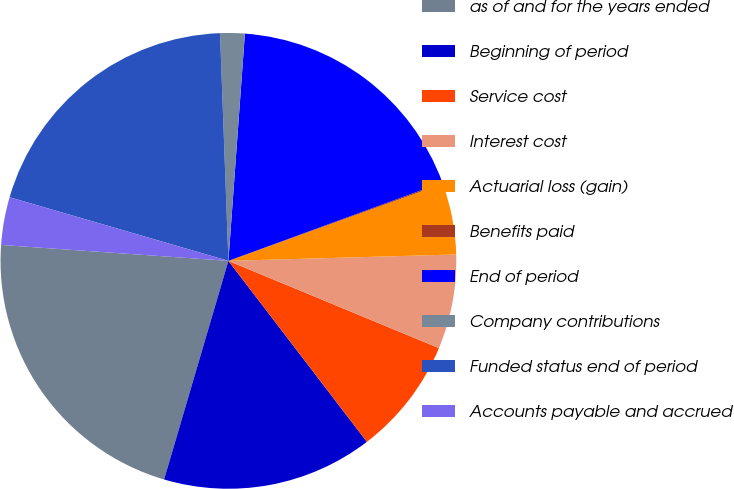Convert chart to OTSL. <chart><loc_0><loc_0><loc_500><loc_500><pie_chart><fcel>as of and for the years ended<fcel>Beginning of period<fcel>Service cost<fcel>Interest cost<fcel>Actuarial loss (gain)<fcel>Benefits paid<fcel>End of period<fcel>Company contributions<fcel>Funded status end of period<fcel>Accounts payable and accrued<nl><fcel>21.56%<fcel>14.95%<fcel>8.35%<fcel>6.7%<fcel>5.05%<fcel>0.09%<fcel>18.26%<fcel>1.74%<fcel>19.91%<fcel>3.39%<nl></chart> 